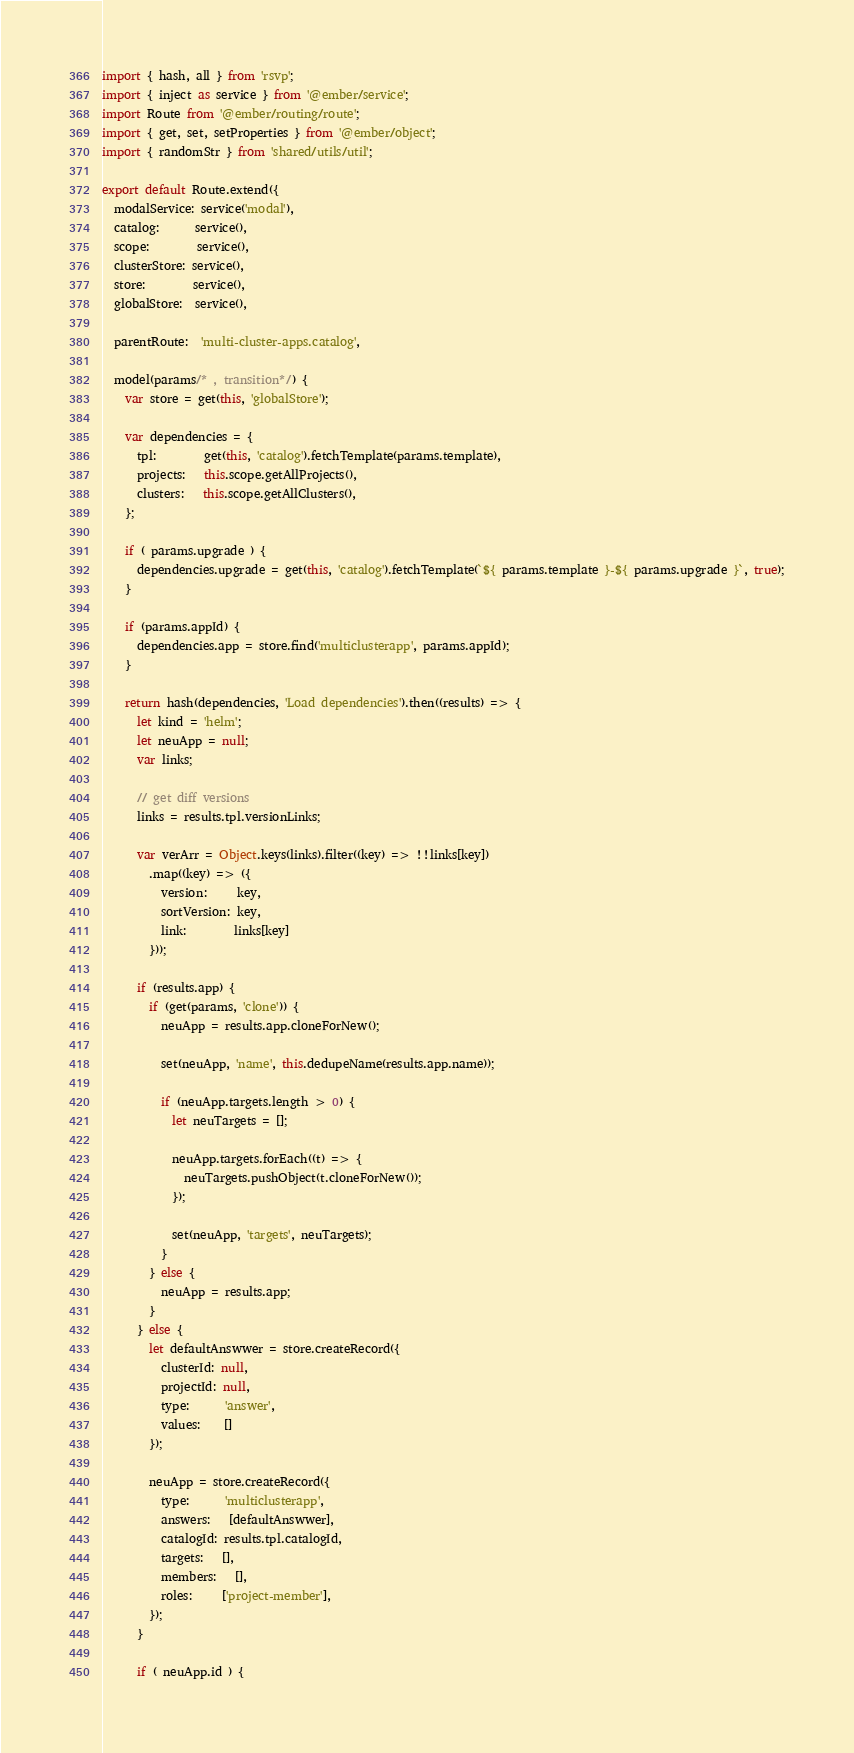<code> <loc_0><loc_0><loc_500><loc_500><_JavaScript_>import { hash, all } from 'rsvp';
import { inject as service } from '@ember/service';
import Route from '@ember/routing/route';
import { get, set, setProperties } from '@ember/object';
import { randomStr } from 'shared/utils/util';

export default Route.extend({
  modalService: service('modal'),
  catalog:      service(),
  scope:        service(),
  clusterStore: service(),
  store:        service(),
  globalStore:  service(),

  parentRoute:  'multi-cluster-apps.catalog',

  model(params/* , transition*/) {
    var store = get(this, 'globalStore');

    var dependencies = {
      tpl:        get(this, 'catalog').fetchTemplate(params.template),
      projects:   this.scope.getAllProjects(),
      clusters:   this.scope.getAllClusters(),
    };

    if ( params.upgrade ) {
      dependencies.upgrade = get(this, 'catalog').fetchTemplate(`${ params.template }-${ params.upgrade }`, true);
    }

    if (params.appId) {
      dependencies.app = store.find('multiclusterapp', params.appId);
    }

    return hash(dependencies, 'Load dependencies').then((results) => {
      let kind = 'helm';
      let neuApp = null;
      var links;

      // get diff versions
      links = results.tpl.versionLinks;

      var verArr = Object.keys(links).filter((key) => !!links[key])
        .map((key) => ({
          version:     key,
          sortVersion: key,
          link:        links[key]
        }));

      if (results.app) {
        if (get(params, 'clone')) {
          neuApp = results.app.cloneForNew();

          set(neuApp, 'name', this.dedupeName(results.app.name));

          if (neuApp.targets.length > 0) {
            let neuTargets = [];

            neuApp.targets.forEach((t) => {
              neuTargets.pushObject(t.cloneForNew());
            });

            set(neuApp, 'targets', neuTargets);
          }
        } else {
          neuApp = results.app;
        }
      } else {
        let defaultAnswwer = store.createRecord({
          clusterId: null,
          projectId: null,
          type:      'answer',
          values:    []
        });

        neuApp = store.createRecord({
          type:      'multiclusterapp',
          answers:   [defaultAnswwer],
          catalogId: results.tpl.catalogId,
          targets:   [],
          members:   [],
          roles:     ['project-member'],
        });
      }

      if ( neuApp.id ) {</code> 